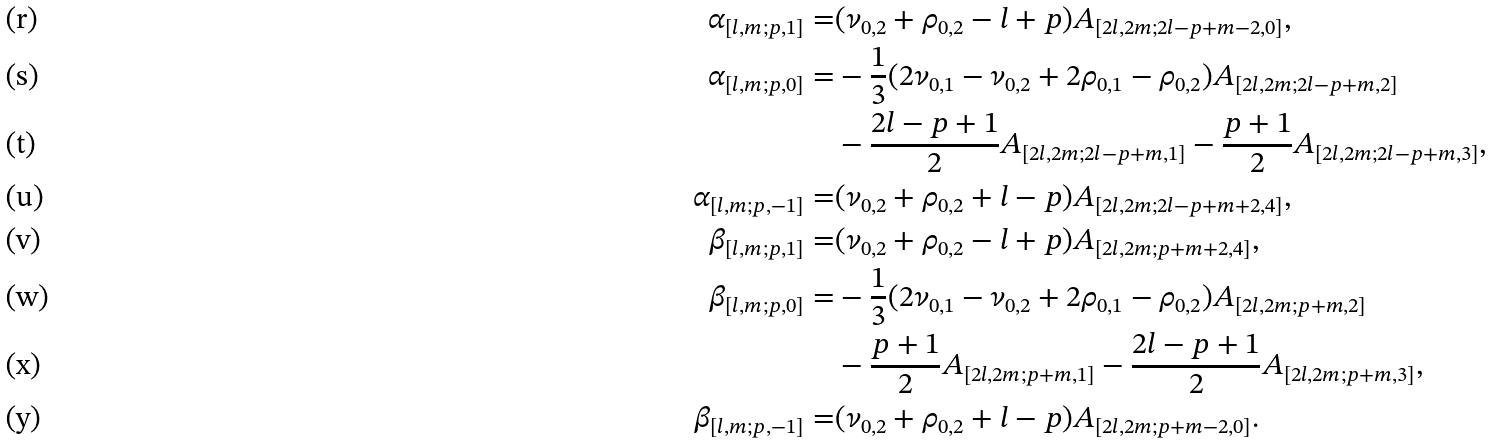Convert formula to latex. <formula><loc_0><loc_0><loc_500><loc_500>\alpha _ { [ l , m ; p , 1 ] } = & ( \nu _ { 0 , 2 } + \rho _ { 0 , 2 } - l + p ) A _ { [ 2 l , 2 m ; 2 l - p + m - 2 , 0 ] } , \\ \alpha _ { [ l , m ; p , 0 ] } = & - \frac { 1 } { 3 } ( 2 \nu _ { 0 , 1 } - \nu _ { 0 , 2 } + 2 \rho _ { 0 , 1 } - \rho _ { 0 , 2 } ) A _ { [ 2 l , 2 m ; 2 l - p + m , 2 ] } \\ & - \frac { 2 l - p + 1 } { 2 } A _ { [ 2 l , 2 m ; 2 l - p + m , 1 ] } - \frac { p + 1 } { 2 } A _ { [ 2 l , 2 m ; 2 l - p + m , 3 ] } , \\ \alpha _ { [ l , m ; p , - 1 ] } = & ( \nu _ { 0 , 2 } + \rho _ { 0 , 2 } + l - p ) A _ { [ 2 l , 2 m ; 2 l - p + m + 2 , 4 ] } , \\ \beta _ { [ l , m ; p , 1 ] } = & ( \nu _ { 0 , 2 } + \rho _ { 0 , 2 } - l + p ) A _ { [ 2 l , 2 m ; p + m + 2 , 4 ] } , \\ \beta _ { [ l , m ; p , 0 ] } = & - \frac { 1 } { 3 } ( 2 \nu _ { 0 , 1 } - \nu _ { 0 , 2 } + 2 \rho _ { 0 , 1 } - \rho _ { 0 , 2 } ) A _ { [ 2 l , 2 m ; p + m , 2 ] } \\ & - \frac { p + 1 } { 2 } A _ { [ 2 l , 2 m ; p + m , 1 ] } - \frac { 2 l - p + 1 } { 2 } A _ { [ 2 l , 2 m ; p + m , 3 ] } , \\ \beta _ { [ l , m ; p , - 1 ] } = & ( \nu _ { 0 , 2 } + \rho _ { 0 , 2 } + l - p ) A _ { [ 2 l , 2 m ; p + m - 2 , 0 ] } .</formula> 